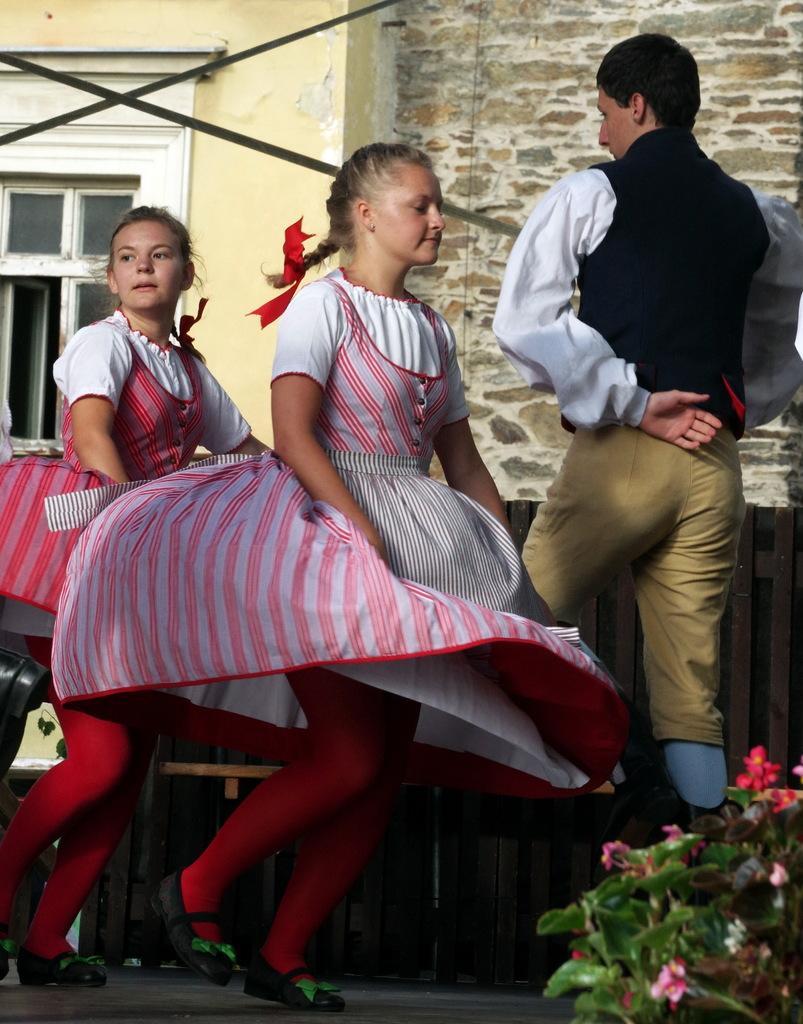How would you summarize this image in a sentence or two? In this picture I can see there are two girls and there is a man standing on the right side and there is a plant at right side and in the backdrop there is a building, it has a window. 